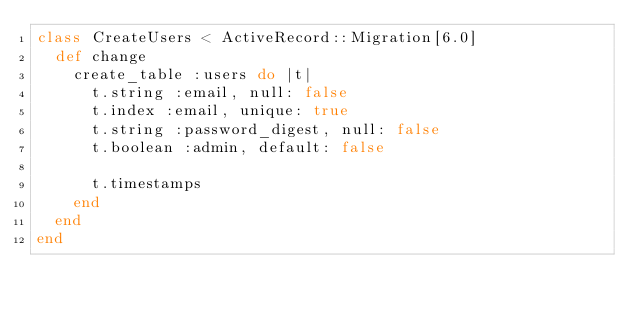Convert code to text. <code><loc_0><loc_0><loc_500><loc_500><_Ruby_>class CreateUsers < ActiveRecord::Migration[6.0]
  def change
    create_table :users do |t|
      t.string :email, null: false
      t.index :email, unique: true
      t.string :password_digest, null: false
      t.boolean :admin, default: false

      t.timestamps
    end
  end
end
</code> 